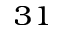<formula> <loc_0><loc_0><loc_500><loc_500>_ { 3 1 }</formula> 